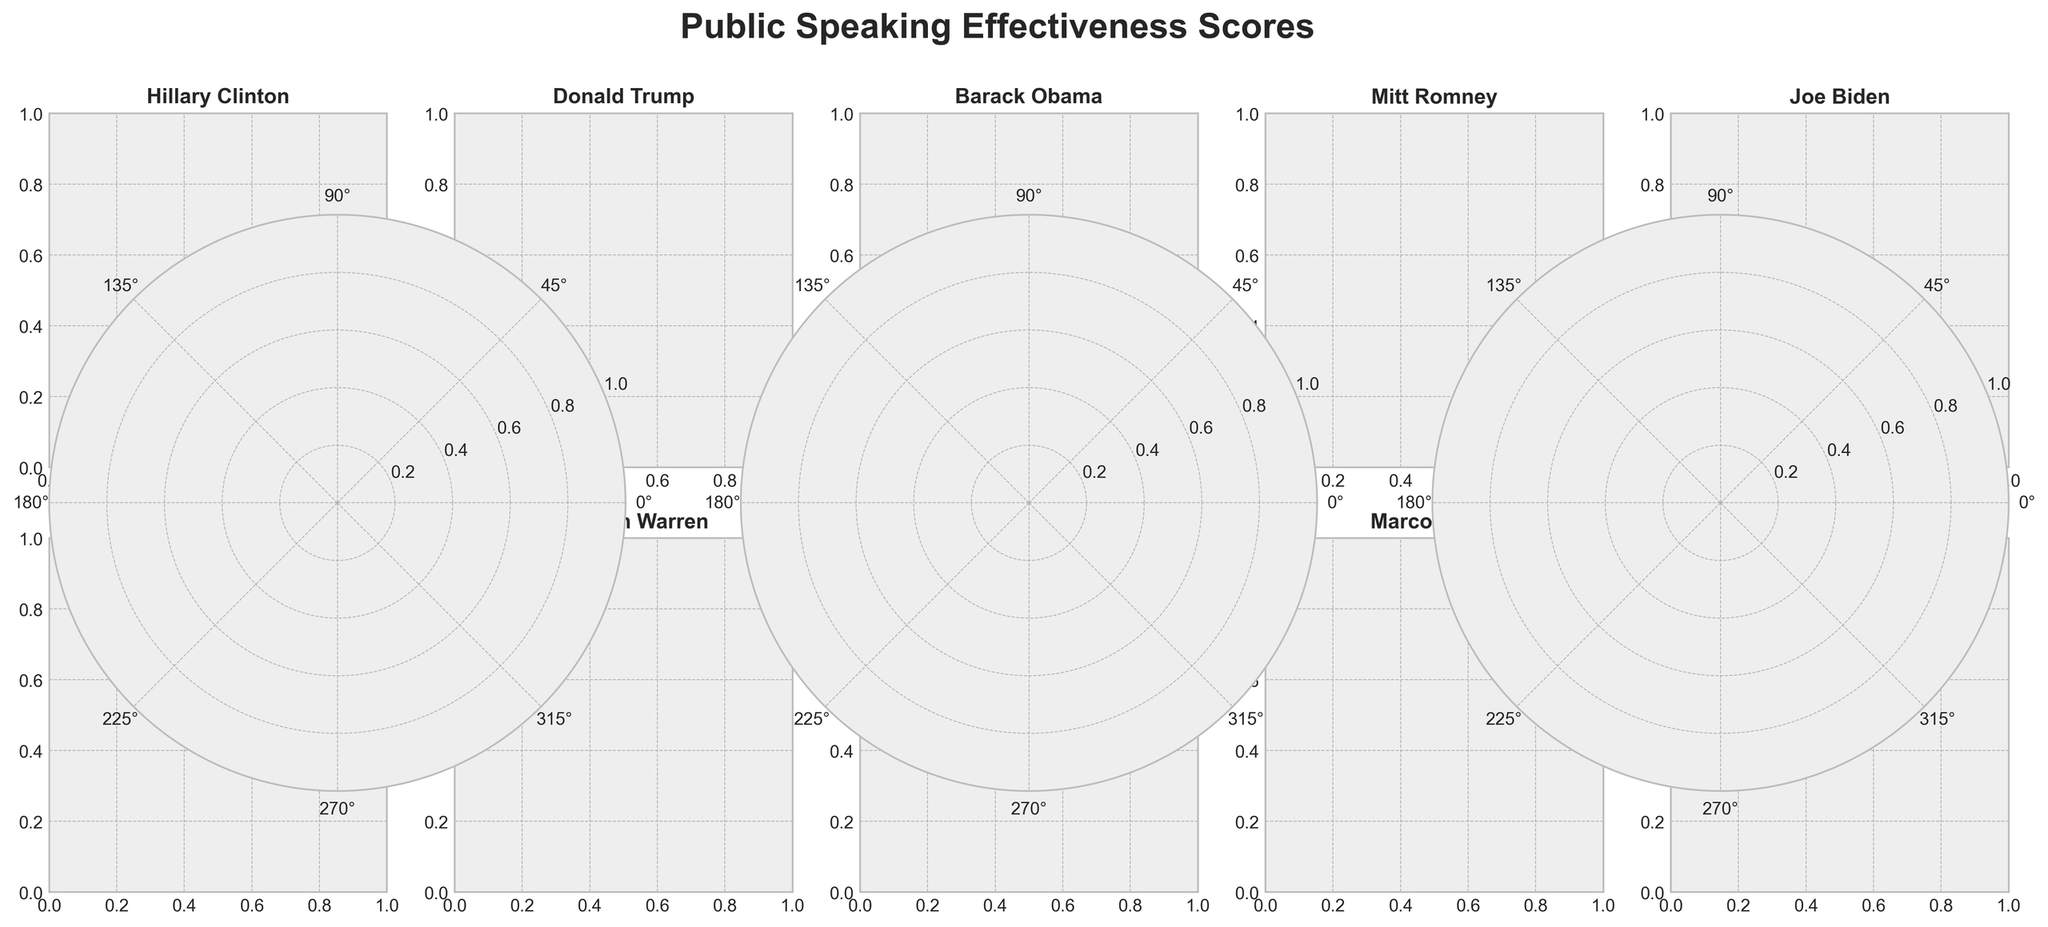Which candidate has the highest clarity score? By inspecting each candidate's Clarity gauge chart, we can identify that Barack Obama has a score of 92, which is the highest.
Answer: Barack Obama Which candidate has the lowest persuasiveness score? By checking the Persuasiveness gauge charts, we observe that Marco Rubio has the lowest score of 77.
Answer: Marco Rubio What is the average engagement score across all candidates? Sum all the Engagement scores and divide by the number of candidates: (78 + 88 + 90 + 75 + 82 + 85 + 80 + 76 + 79 + 81) / 10 = 81.4
Answer: 81.4 Compare the engagement scores of Donald Trump and Kamala Harris. Who is more engaging? Donald Trump has an engagement score of 88 while Kamala Harris has a score of 81. Thus, Donald Trump is more engaging.
Answer: Donald Trump Which metric of Bernie Sanders is the highest, and what is its value? By observing Bernie Sanders' gauges, we see Clarity is 88, Engagement is 85, and Persuasiveness is 83. His highest metric is Clarity with a score of 88.
Answer: Clarity, 88 What is the difference between Joe Biden's clarity and persuasiveness scores? Joe Biden's Clarity score is 78 and his Persuasiveness score is 80. The difference is 80 - 78 = 2.
Answer: 2 Who has a higher persuasiveness score, Ted Cruz or Elizabeth Warren? Ted Cruz has a Persuasiveness score of 81, whereas Elizabeth Warren has a score of 85. Elizabeth Warren's score is higher.
Answer: Elizabeth Warren What fraction of candidates have clarity scores above 80? The candidates with clarity scores above 80 are Hillary Clinton, Barack Obama, Bernie Sanders, Elizabeth Warren, and Kamala Harris. There are 5 such candidates out of 10 total candidates. The fraction is 5/10 which simplifies to 1/2.
Answer: 1/2 Combine the clarity and engagement scores of Mitt Romney. What is the sum? Mitt Romney's Clarity score is 80 and his Engagement score is 75. The sum is 80 + 75 = 155.
Answer: 155 